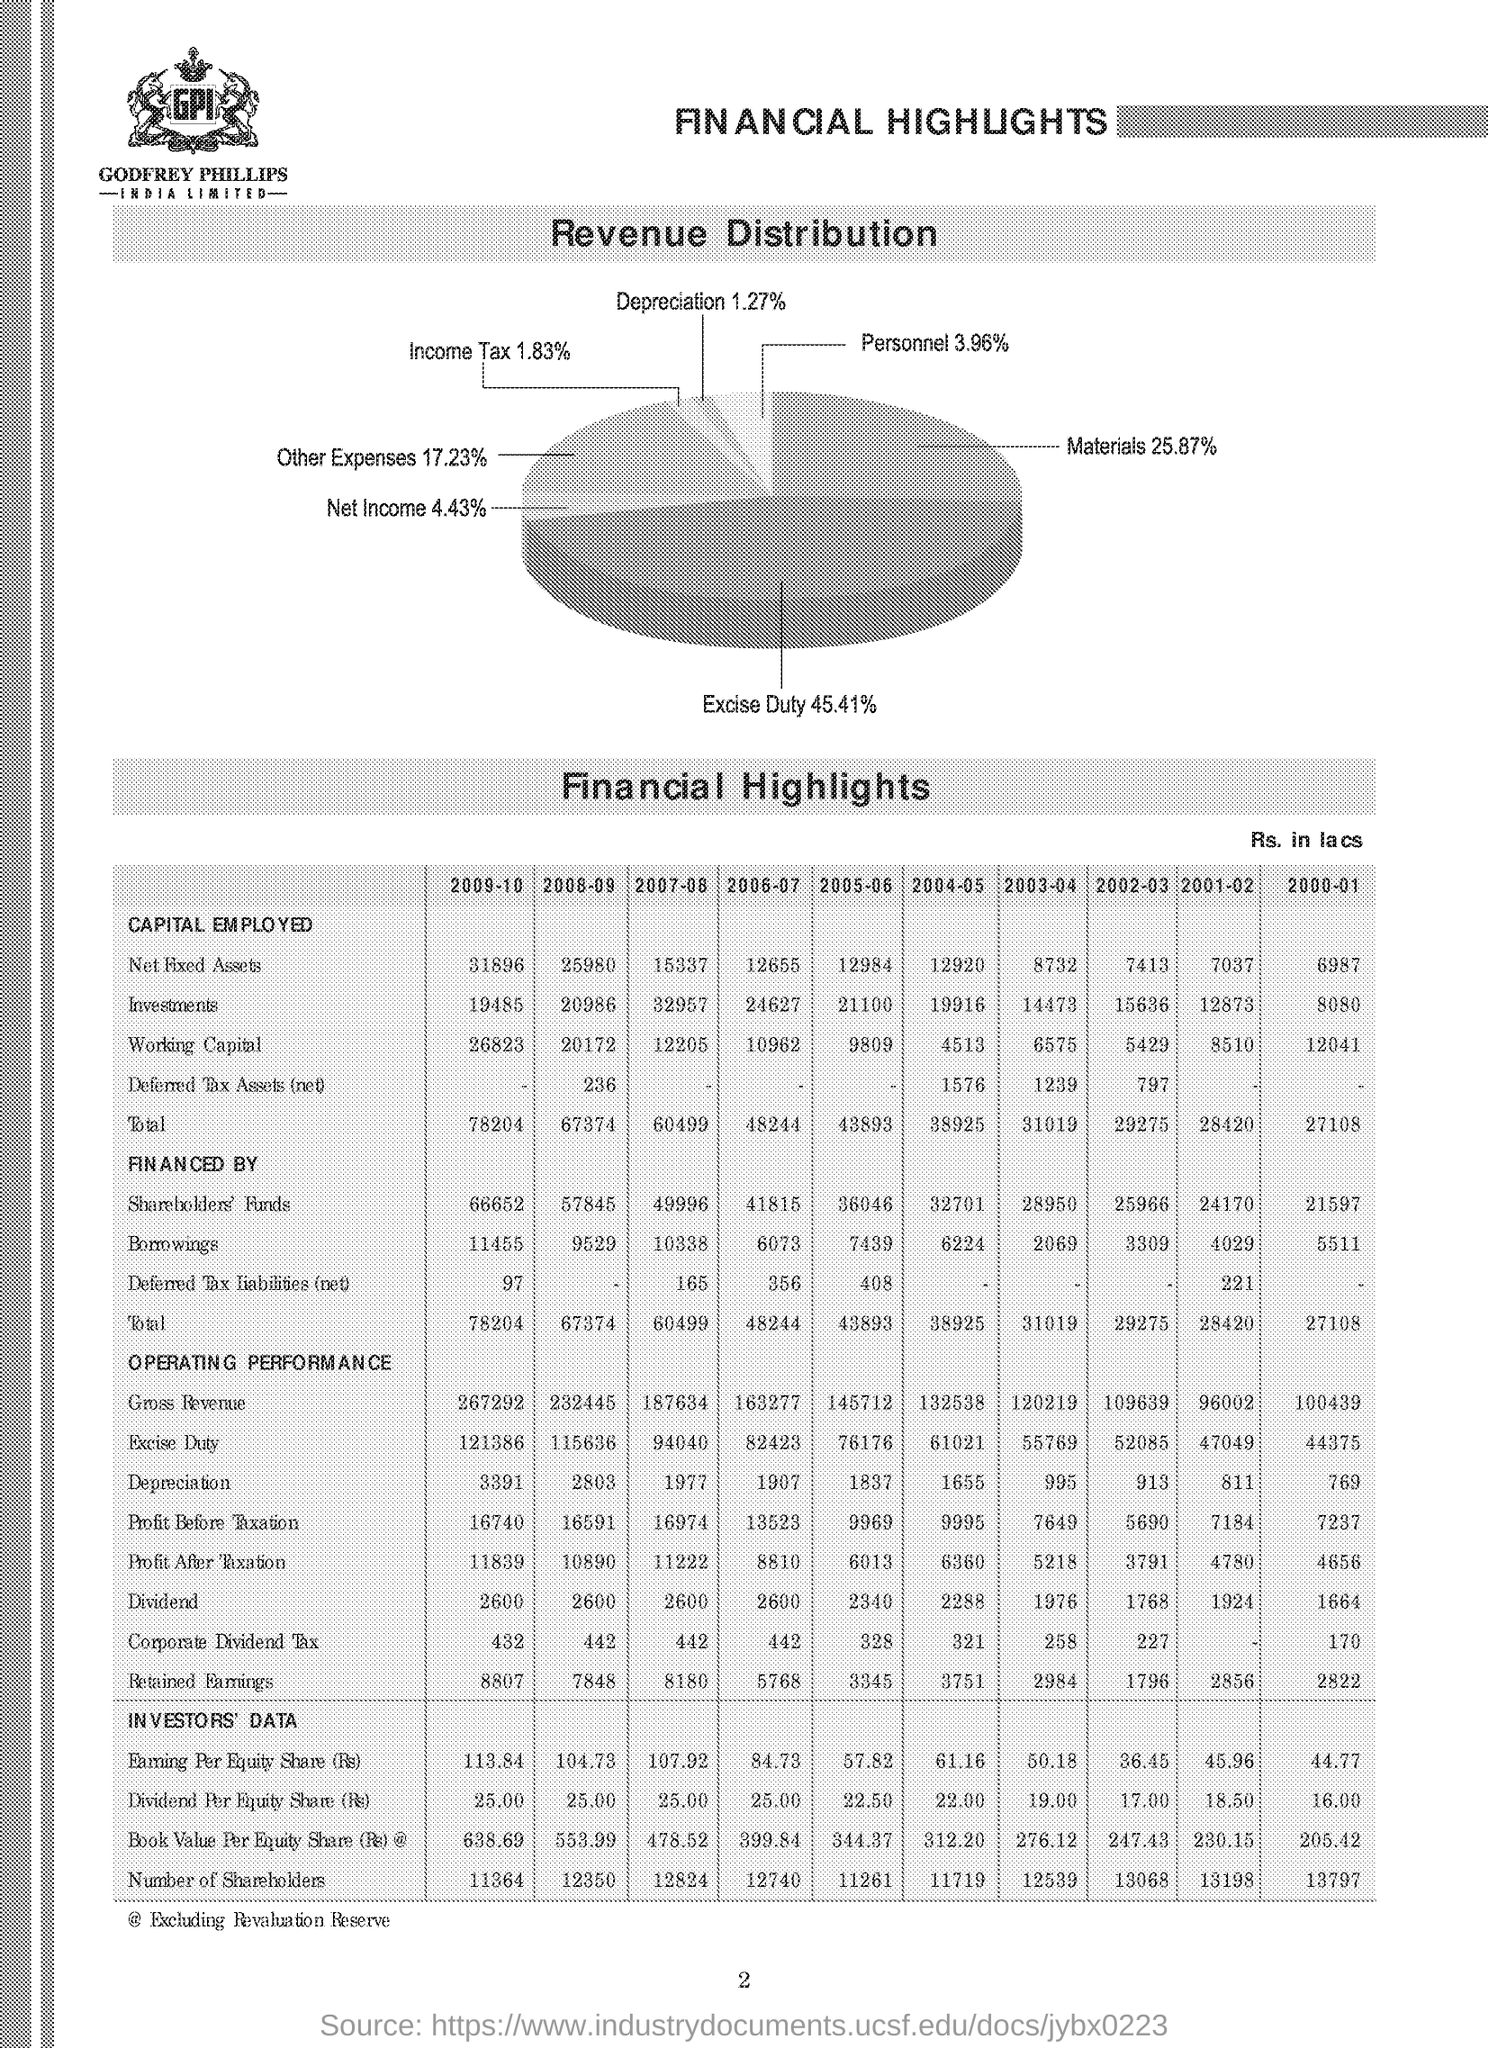What is the pattern in the company's Borrowings over the years? The Borrowings show a varied pattern, initially decreasing from 5511 in 2000-01 to a low of 4029 in 2003-04, followed by a steady rise every year to reach 9519 in 2009-10, indicating an increasing reliance on borrowed funds over the years. 